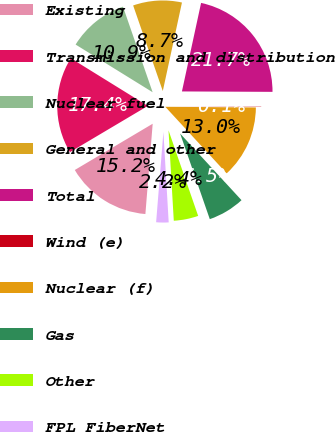Convert chart. <chart><loc_0><loc_0><loc_500><loc_500><pie_chart><fcel>Existing<fcel>Transmission and distribution<fcel>Nuclear fuel<fcel>General and other<fcel>Total<fcel>Wind (e)<fcel>Nuclear (f)<fcel>Gas<fcel>Other<fcel>FPL FiberNet<nl><fcel>15.19%<fcel>17.35%<fcel>10.87%<fcel>8.7%<fcel>21.68%<fcel>0.05%<fcel>13.03%<fcel>6.54%<fcel>4.38%<fcel>2.21%<nl></chart> 